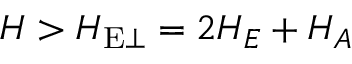Convert formula to latex. <formula><loc_0><loc_0><loc_500><loc_500>H > H _ { E \perp } = 2 H _ { E } + H _ { A }</formula> 